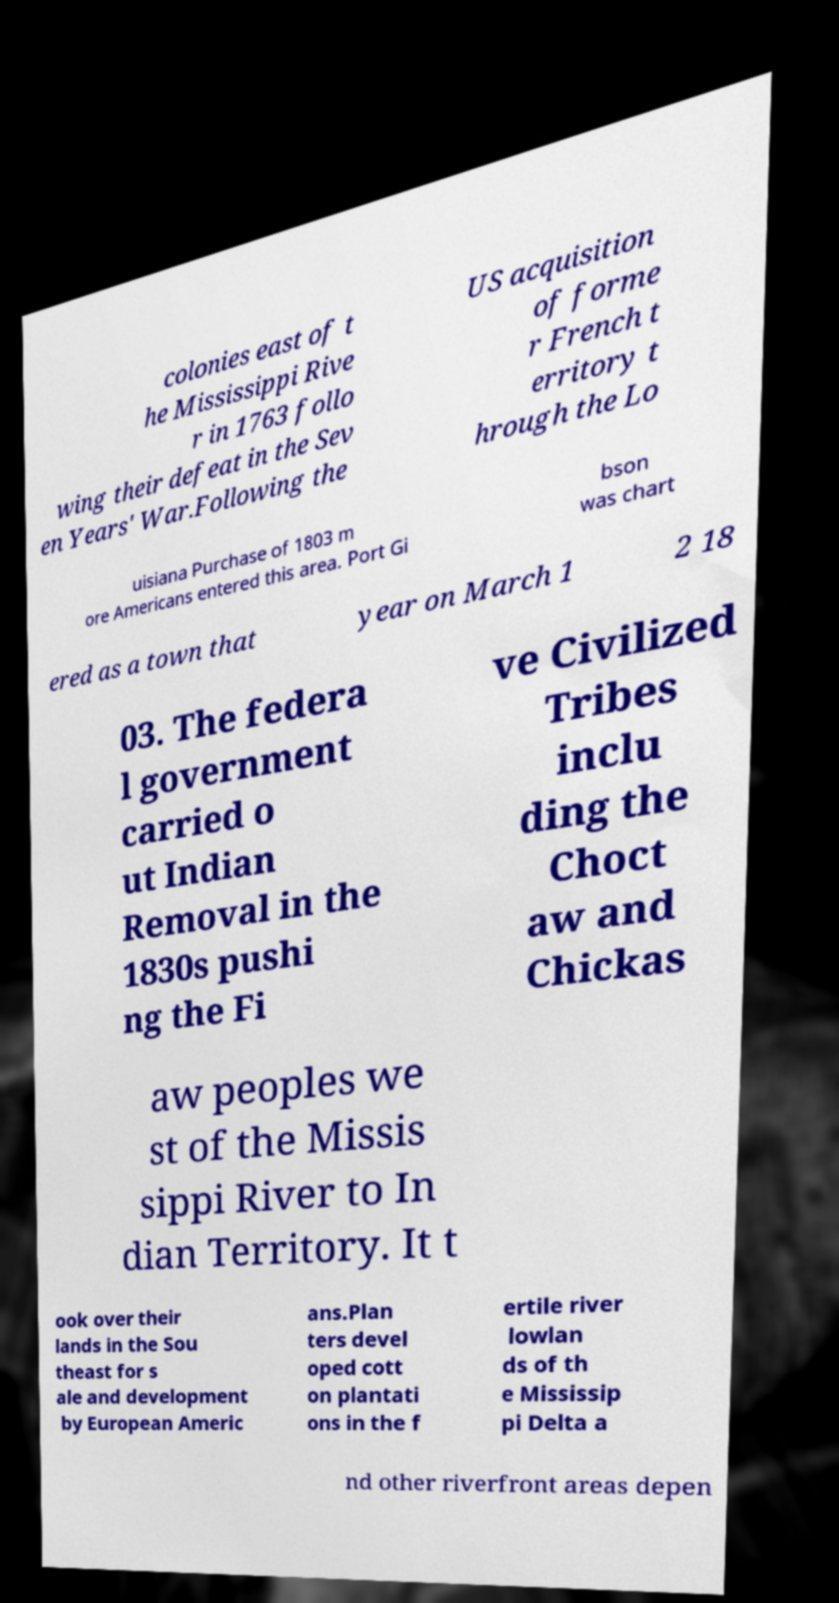Please identify and transcribe the text found in this image. colonies east of t he Mississippi Rive r in 1763 follo wing their defeat in the Sev en Years' War.Following the US acquisition of forme r French t erritory t hrough the Lo uisiana Purchase of 1803 m ore Americans entered this area. Port Gi bson was chart ered as a town that year on March 1 2 18 03. The federa l government carried o ut Indian Removal in the 1830s pushi ng the Fi ve Civilized Tribes inclu ding the Choct aw and Chickas aw peoples we st of the Missis sippi River to In dian Territory. It t ook over their lands in the Sou theast for s ale and development by European Americ ans.Plan ters devel oped cott on plantati ons in the f ertile river lowlan ds of th e Mississip pi Delta a nd other riverfront areas depen 